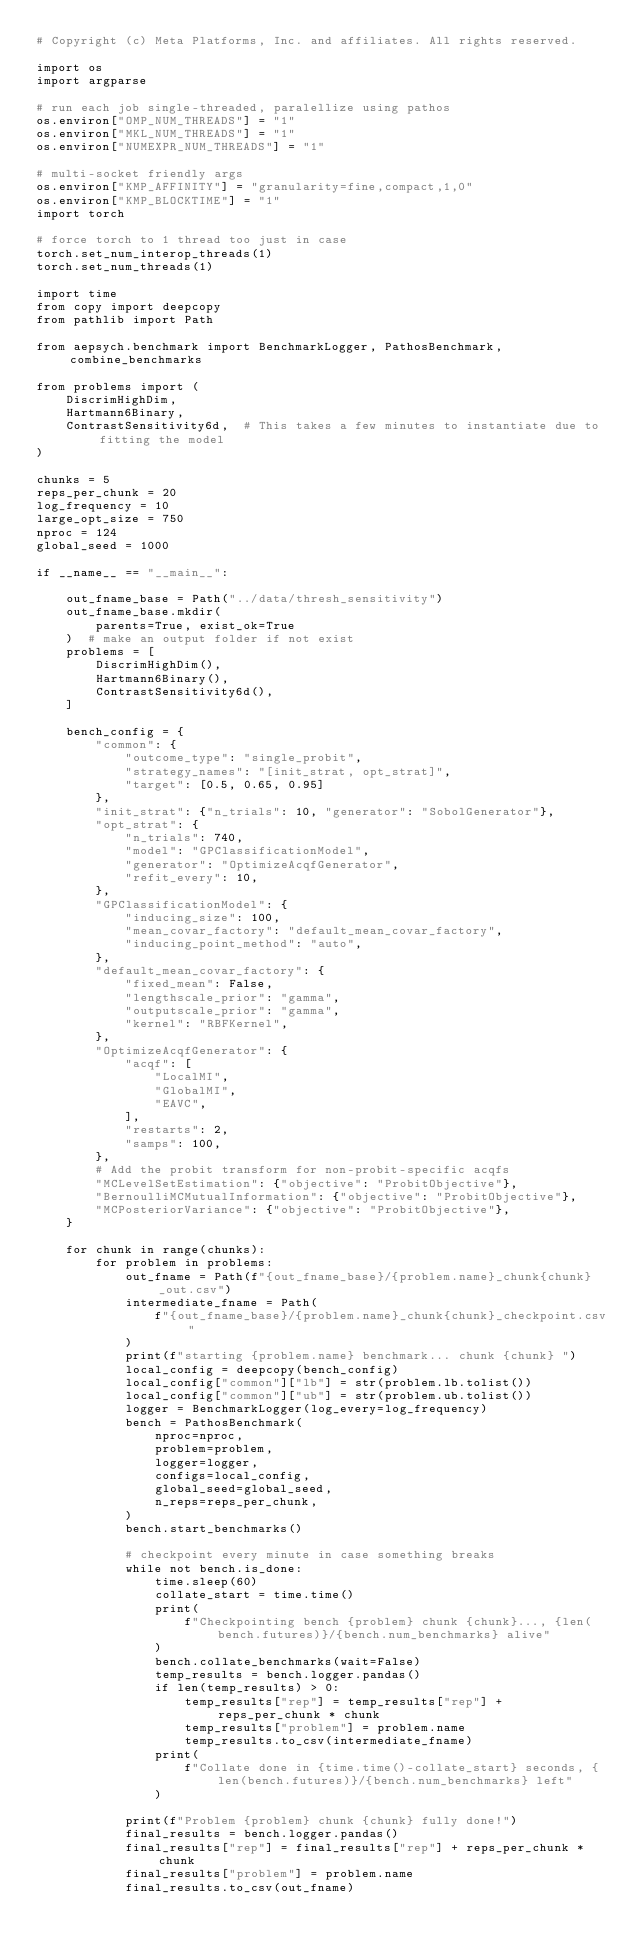<code> <loc_0><loc_0><loc_500><loc_500><_Python_># Copyright (c) Meta Platforms, Inc. and affiliates. All rights reserved.

import os
import argparse

# run each job single-threaded, paralellize using pathos
os.environ["OMP_NUM_THREADS"] = "1"
os.environ["MKL_NUM_THREADS"] = "1"
os.environ["NUMEXPR_NUM_THREADS"] = "1"

# multi-socket friendly args
os.environ["KMP_AFFINITY"] = "granularity=fine,compact,1,0"
os.environ["KMP_BLOCKTIME"] = "1"
import torch

# force torch to 1 thread too just in case
torch.set_num_interop_threads(1)
torch.set_num_threads(1)

import time
from copy import deepcopy
from pathlib import Path

from aepsych.benchmark import BenchmarkLogger, PathosBenchmark, combine_benchmarks

from problems import (
    DiscrimHighDim,
    Hartmann6Binary,
    ContrastSensitivity6d,  # This takes a few minutes to instantiate due to fitting the model
)

chunks = 5
reps_per_chunk = 20
log_frequency = 10
large_opt_size = 750
nproc = 124
global_seed = 1000

if __name__ == "__main__":

    out_fname_base = Path("../data/thresh_sensitivity")
    out_fname_base.mkdir(
        parents=True, exist_ok=True
    )  # make an output folder if not exist
    problems = [
        DiscrimHighDim(),
        Hartmann6Binary(),
        ContrastSensitivity6d(),
    ]

    bench_config = {
        "common": {
            "outcome_type": "single_probit",
            "strategy_names": "[init_strat, opt_strat]",
            "target": [0.5, 0.65, 0.95]
        },
        "init_strat": {"n_trials": 10, "generator": "SobolGenerator"},
        "opt_strat": {
            "n_trials": 740,
            "model": "GPClassificationModel",
            "generator": "OptimizeAcqfGenerator",
            "refit_every": 10,
        },
        "GPClassificationModel": {
            "inducing_size": 100,
            "mean_covar_factory": "default_mean_covar_factory",
            "inducing_point_method": "auto",
        },
        "default_mean_covar_factory": {
            "fixed_mean": False,
            "lengthscale_prior": "gamma",
            "outputscale_prior": "gamma",
            "kernel": "RBFKernel",
        },
        "OptimizeAcqfGenerator": {
            "acqf": [
                "LocalMI",
                "GlobalMI",
                "EAVC",
            ],
            "restarts": 2,
            "samps": 100,
        },
        # Add the probit transform for non-probit-specific acqfs
        "MCLevelSetEstimation": {"objective": "ProbitObjective"},
        "BernoulliMCMutualInformation": {"objective": "ProbitObjective"},
        "MCPosteriorVariance": {"objective": "ProbitObjective"},
    }

    for chunk in range(chunks):
        for problem in problems:
            out_fname = Path(f"{out_fname_base}/{problem.name}_chunk{chunk}_out.csv")
            intermediate_fname = Path(
                f"{out_fname_base}/{problem.name}_chunk{chunk}_checkpoint.csv"
            )
            print(f"starting {problem.name} benchmark... chunk {chunk} ")
            local_config = deepcopy(bench_config)
            local_config["common"]["lb"] = str(problem.lb.tolist())
            local_config["common"]["ub"] = str(problem.ub.tolist())
            logger = BenchmarkLogger(log_every=log_frequency)
            bench = PathosBenchmark(
                nproc=nproc,
                problem=problem,
                logger=logger,
                configs=local_config,
                global_seed=global_seed,
                n_reps=reps_per_chunk,
            )
            bench.start_benchmarks()

            # checkpoint every minute in case something breaks
            while not bench.is_done:
                time.sleep(60)
                collate_start = time.time()
                print(
                    f"Checkpointing bench {problem} chunk {chunk}..., {len(bench.futures)}/{bench.num_benchmarks} alive"
                )
                bench.collate_benchmarks(wait=False)
                temp_results = bench.logger.pandas()
                if len(temp_results) > 0:
                    temp_results["rep"] = temp_results["rep"] + reps_per_chunk * chunk
                    temp_results["problem"] = problem.name
                    temp_results.to_csv(intermediate_fname)
                print(
                    f"Collate done in {time.time()-collate_start} seconds, {len(bench.futures)}/{bench.num_benchmarks} left"
                )

            print(f"Problem {problem} chunk {chunk} fully done!")
            final_results = bench.logger.pandas()
            final_results["rep"] = final_results["rep"] + reps_per_chunk * chunk
            final_results["problem"] = problem.name
            final_results.to_csv(out_fname)
</code> 